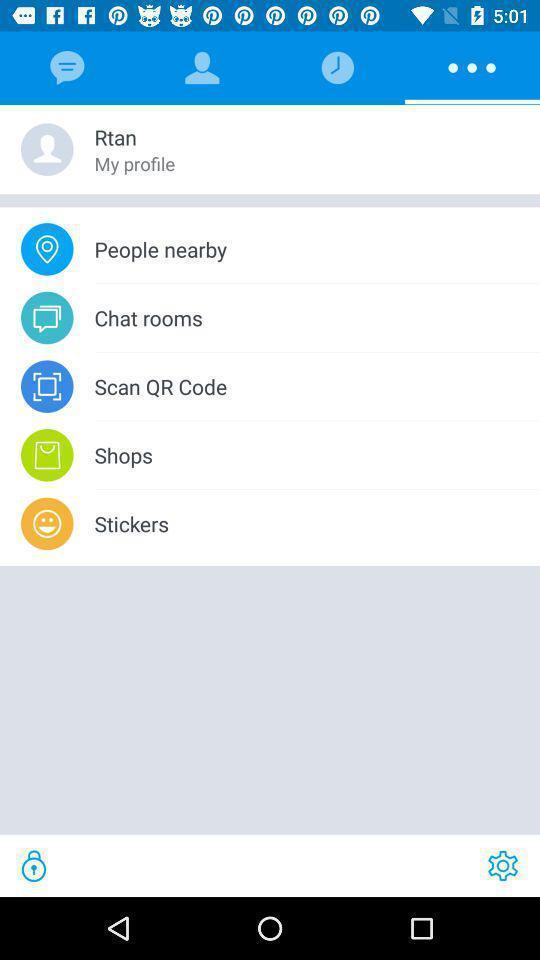Give me a summary of this screen capture. Screen shows more options page in the app. 